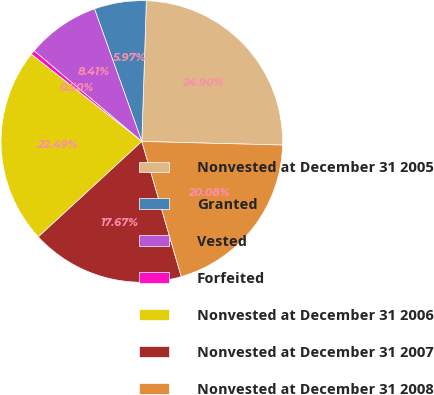<chart> <loc_0><loc_0><loc_500><loc_500><pie_chart><fcel>Nonvested at December 31 2005<fcel>Granted<fcel>Vested<fcel>Forfeited<fcel>Nonvested at December 31 2006<fcel>Nonvested at December 31 2007<fcel>Nonvested at December 31 2008<nl><fcel>24.9%<fcel>5.97%<fcel>8.41%<fcel>0.5%<fcel>22.49%<fcel>17.67%<fcel>20.08%<nl></chart> 